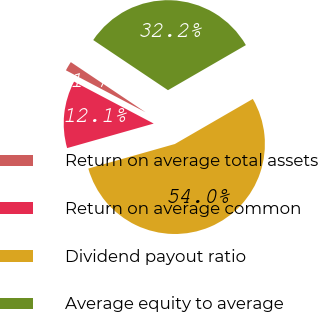<chart> <loc_0><loc_0><loc_500><loc_500><pie_chart><fcel>Return on average total assets<fcel>Return on average common<fcel>Dividend payout ratio<fcel>Average equity to average<nl><fcel>1.69%<fcel>12.11%<fcel>53.95%<fcel>32.25%<nl></chart> 